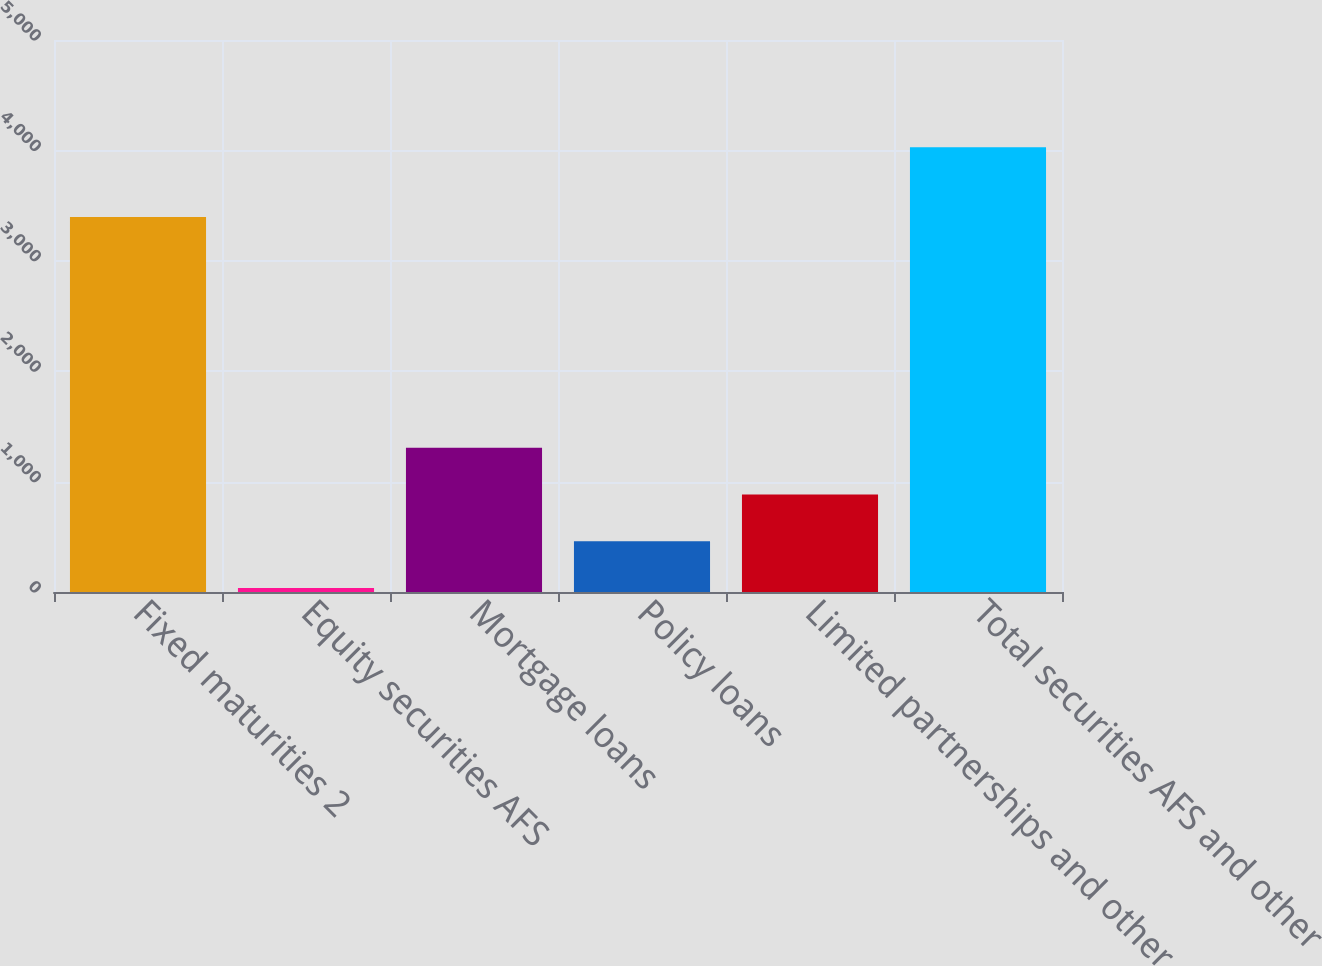Convert chart. <chart><loc_0><loc_0><loc_500><loc_500><bar_chart><fcel>Fixed maturities 2<fcel>Equity securities AFS<fcel>Mortgage loans<fcel>Policy loans<fcel>Limited partnerships and other<fcel>Total securities AFS and other<nl><fcel>3396<fcel>36<fcel>1306.8<fcel>459.6<fcel>883.2<fcel>4029<nl></chart> 